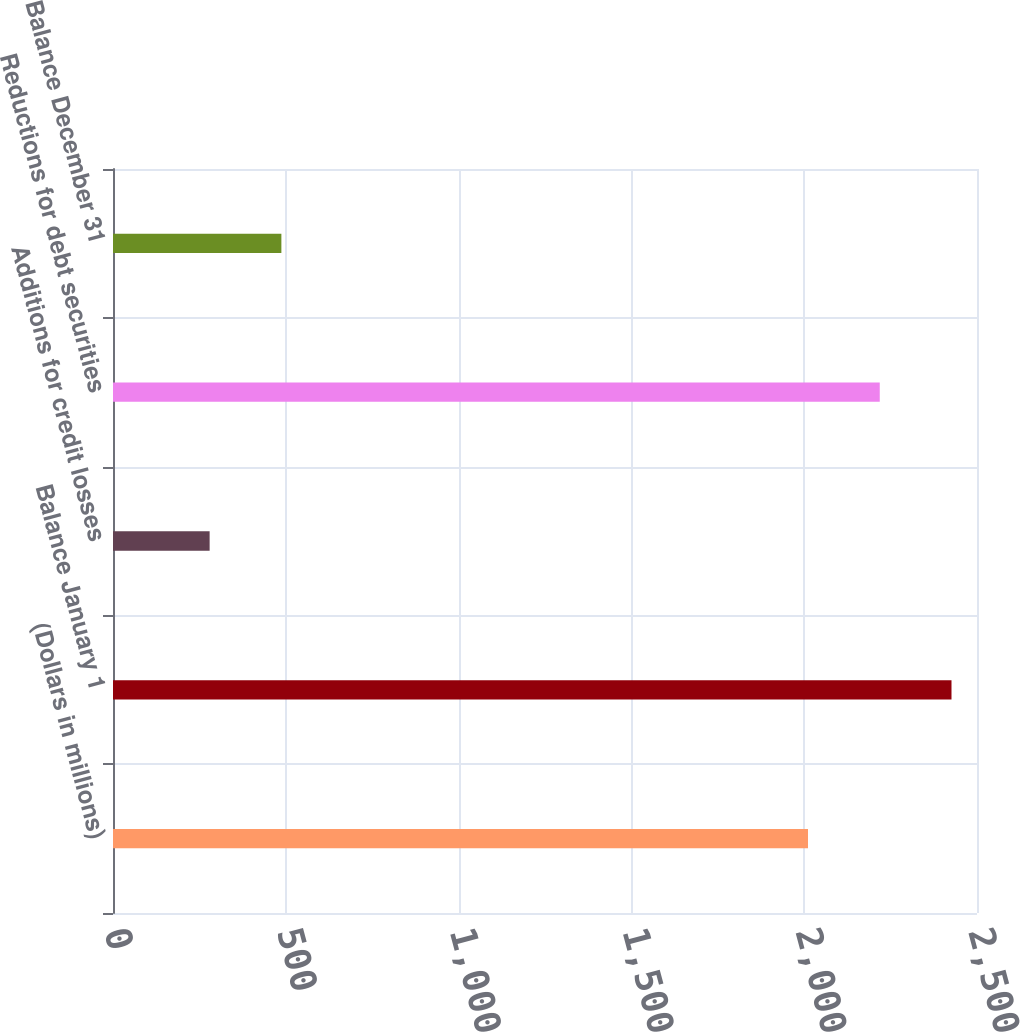Convert chart to OTSL. <chart><loc_0><loc_0><loc_500><loc_500><bar_chart><fcel>(Dollars in millions)<fcel>Balance January 1<fcel>Additions for credit losses<fcel>Reductions for debt securities<fcel>Balance December 31<nl><fcel>2011<fcel>2426.2<fcel>279.6<fcel>2218.6<fcel>487.2<nl></chart> 